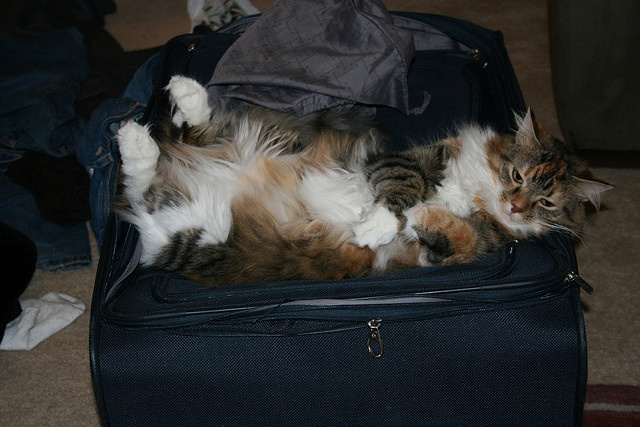Describe the objects in this image and their specific colors. I can see suitcase in black, gray, and darkblue tones and cat in black, darkgray, and gray tones in this image. 